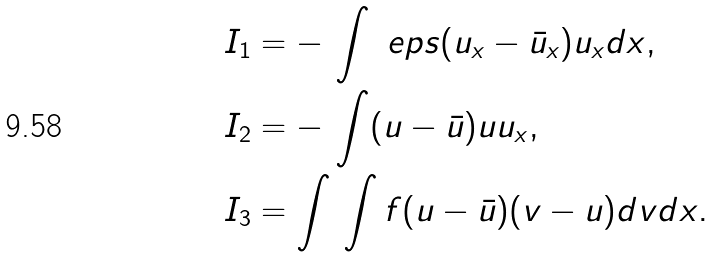Convert formula to latex. <formula><loc_0><loc_0><loc_500><loc_500>I _ { 1 } & = - \, \int \ e p s ( u _ { x } - \bar { u } _ { x } ) u _ { x } d x , \\ I _ { 2 } & = - \, \int ( u - \bar { u } ) u u _ { x } , \\ I _ { 3 } & = \int \, \int f ( u - \bar { u } ) ( v - u ) d v d x .</formula> 